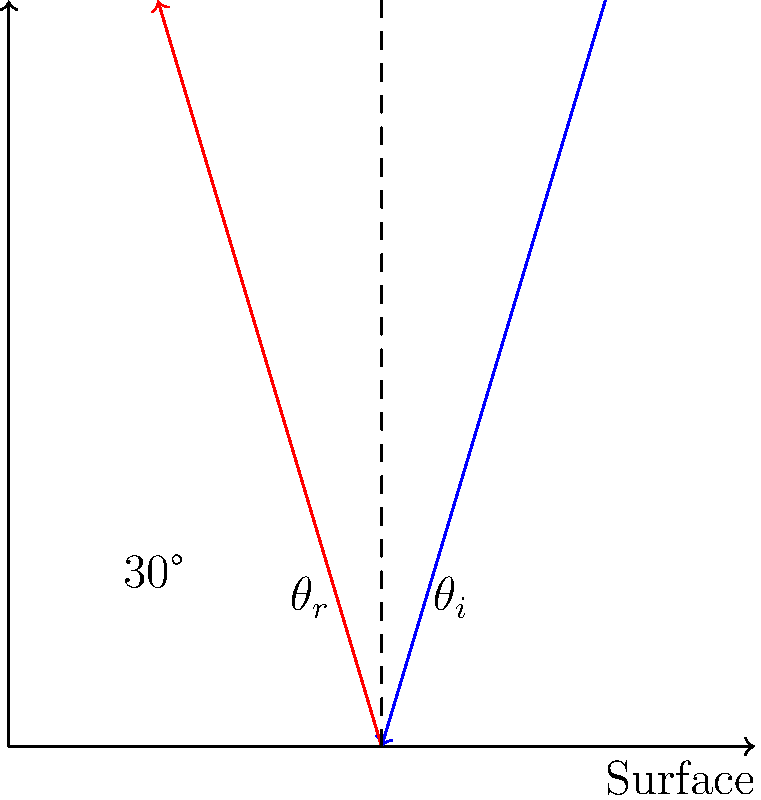In the diagram above, a sound wave is reflected off a flat surface in a recording studio. The angle of reflection ($\theta_r$) is shown to be 30°. What is the angle of incidence ($\theta_i$)? To solve this problem, we need to understand the law of reflection for sound waves:

1. The law of reflection states that the angle of incidence ($\theta_i$) is equal to the angle of reflection ($\theta_r$).

2. In the diagram, we can see that the angle of reflection ($\theta_r$) is given as 30°.

3. Since $\theta_i = \theta_r$, we can conclude that the angle of incidence ($\theta_i$) must also be 30°.

4. This principle is crucial in soundproofing and acoustic design, as it helps predict how sound waves will behave when they encounter surfaces in a recording studio.
Answer: 30° 